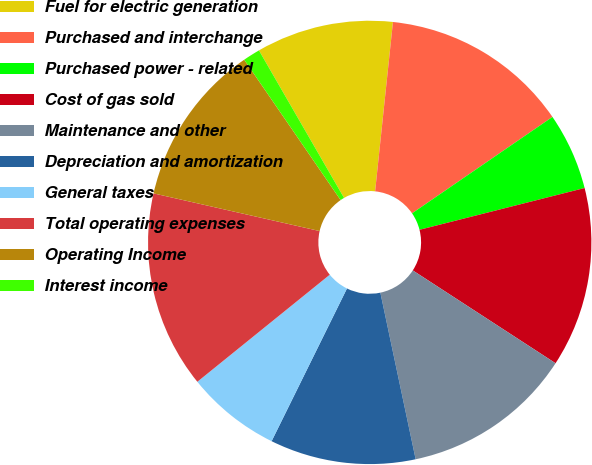<chart> <loc_0><loc_0><loc_500><loc_500><pie_chart><fcel>Fuel for electric generation<fcel>Purchased and interchange<fcel>Purchased power - related<fcel>Cost of gas sold<fcel>Maintenance and other<fcel>Depreciation and amortization<fcel>General taxes<fcel>Total operating expenses<fcel>Operating Income<fcel>Interest income<nl><fcel>10.0%<fcel>13.75%<fcel>5.63%<fcel>13.12%<fcel>12.5%<fcel>10.62%<fcel>6.88%<fcel>14.37%<fcel>11.87%<fcel>1.25%<nl></chart> 